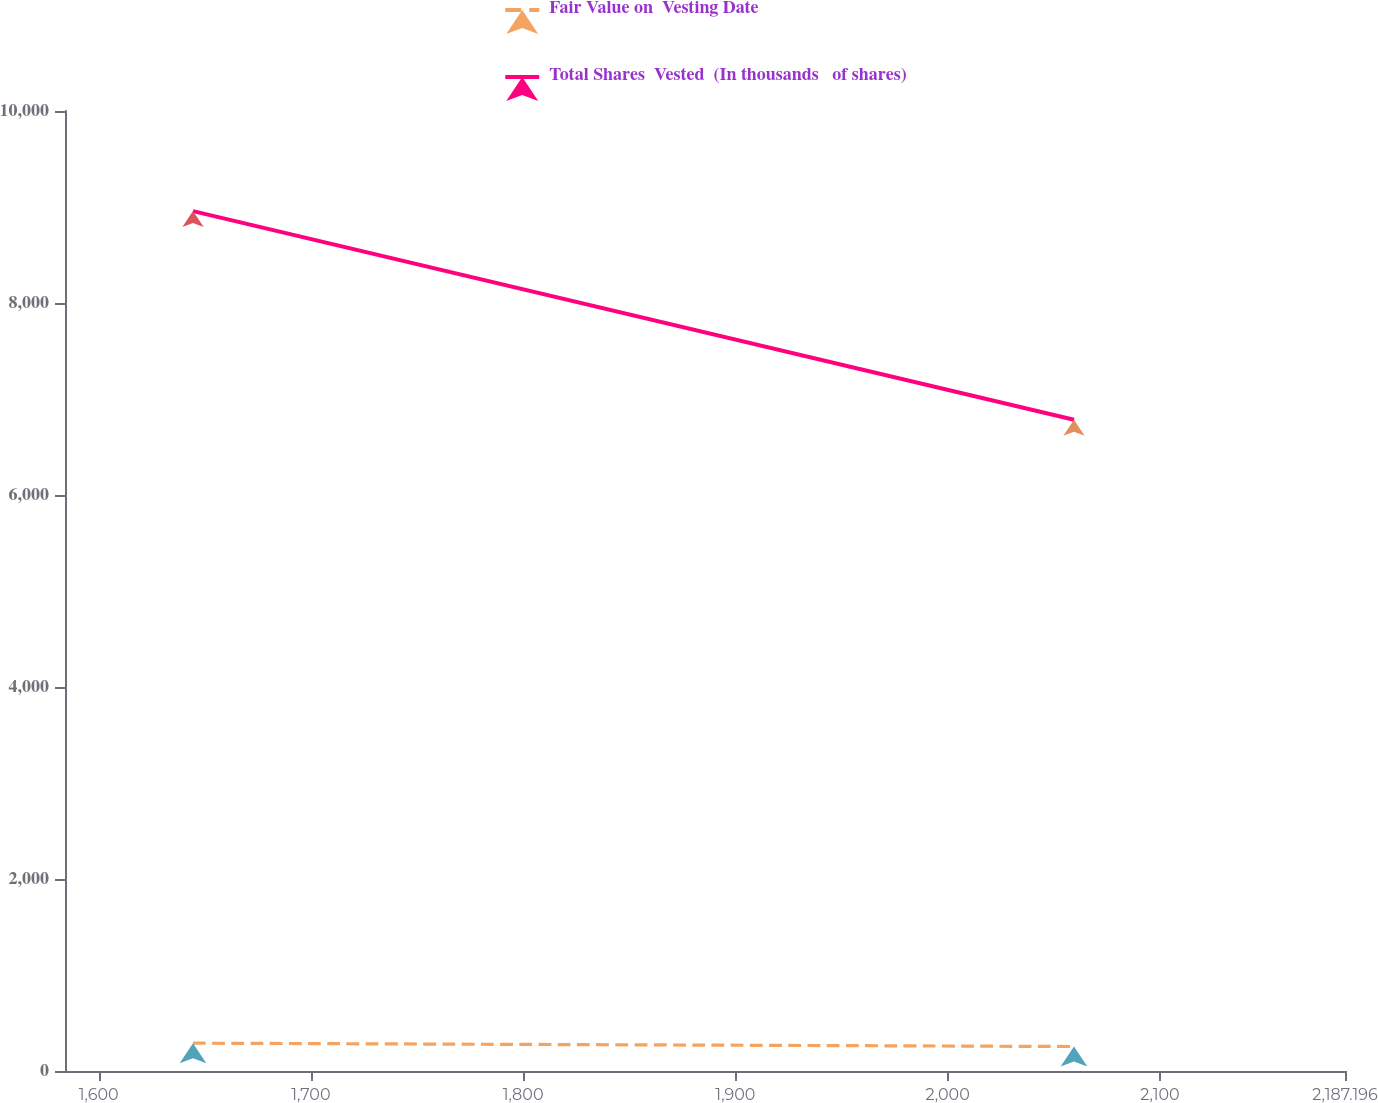<chart> <loc_0><loc_0><loc_500><loc_500><line_chart><ecel><fcel>Fair Value on  Vesting Date<fcel>Total Shares  Vested  (In thousands   of shares)<nl><fcel>1644.46<fcel>290.06<fcel>8957.35<nl><fcel>2059.51<fcel>255.03<fcel>6784.33<nl><fcel>2247.5<fcel>314.7<fcel>9178.98<nl></chart> 